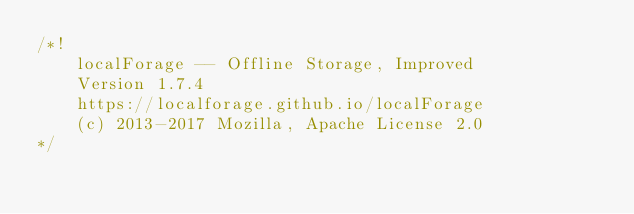Convert code to text. <code><loc_0><loc_0><loc_500><loc_500><_JavaScript_>/*!
    localForage -- Offline Storage, Improved
    Version 1.7.4
    https://localforage.github.io/localForage
    (c) 2013-2017 Mozilla, Apache License 2.0
*/</code> 